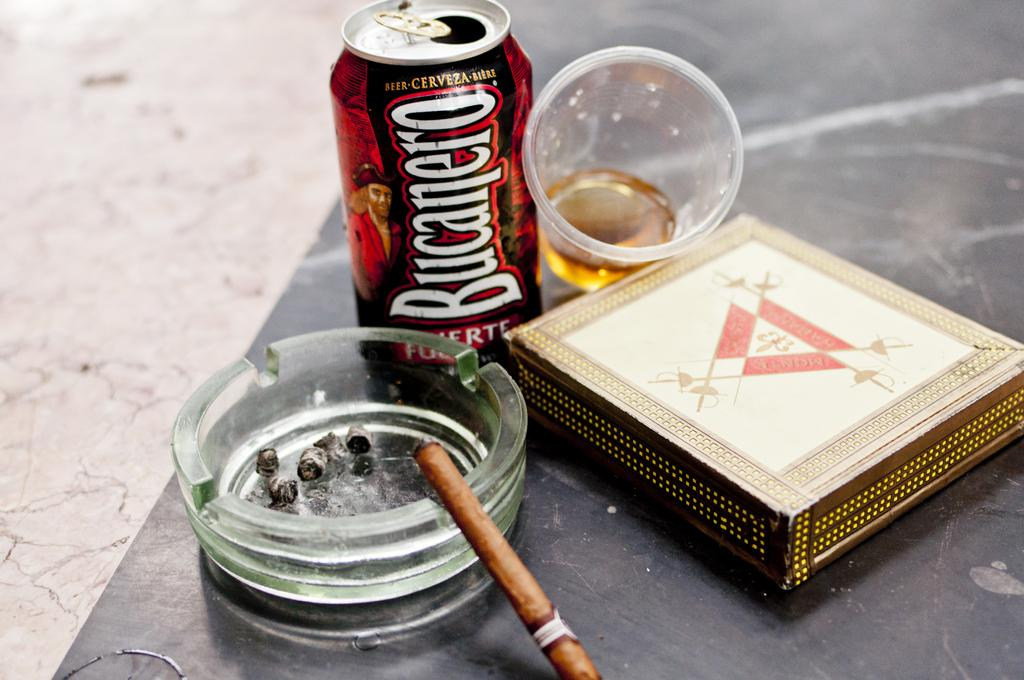<image>
Share a concise interpretation of the image provided. An ashtray and a can of Bucanero with a cup beside it. 